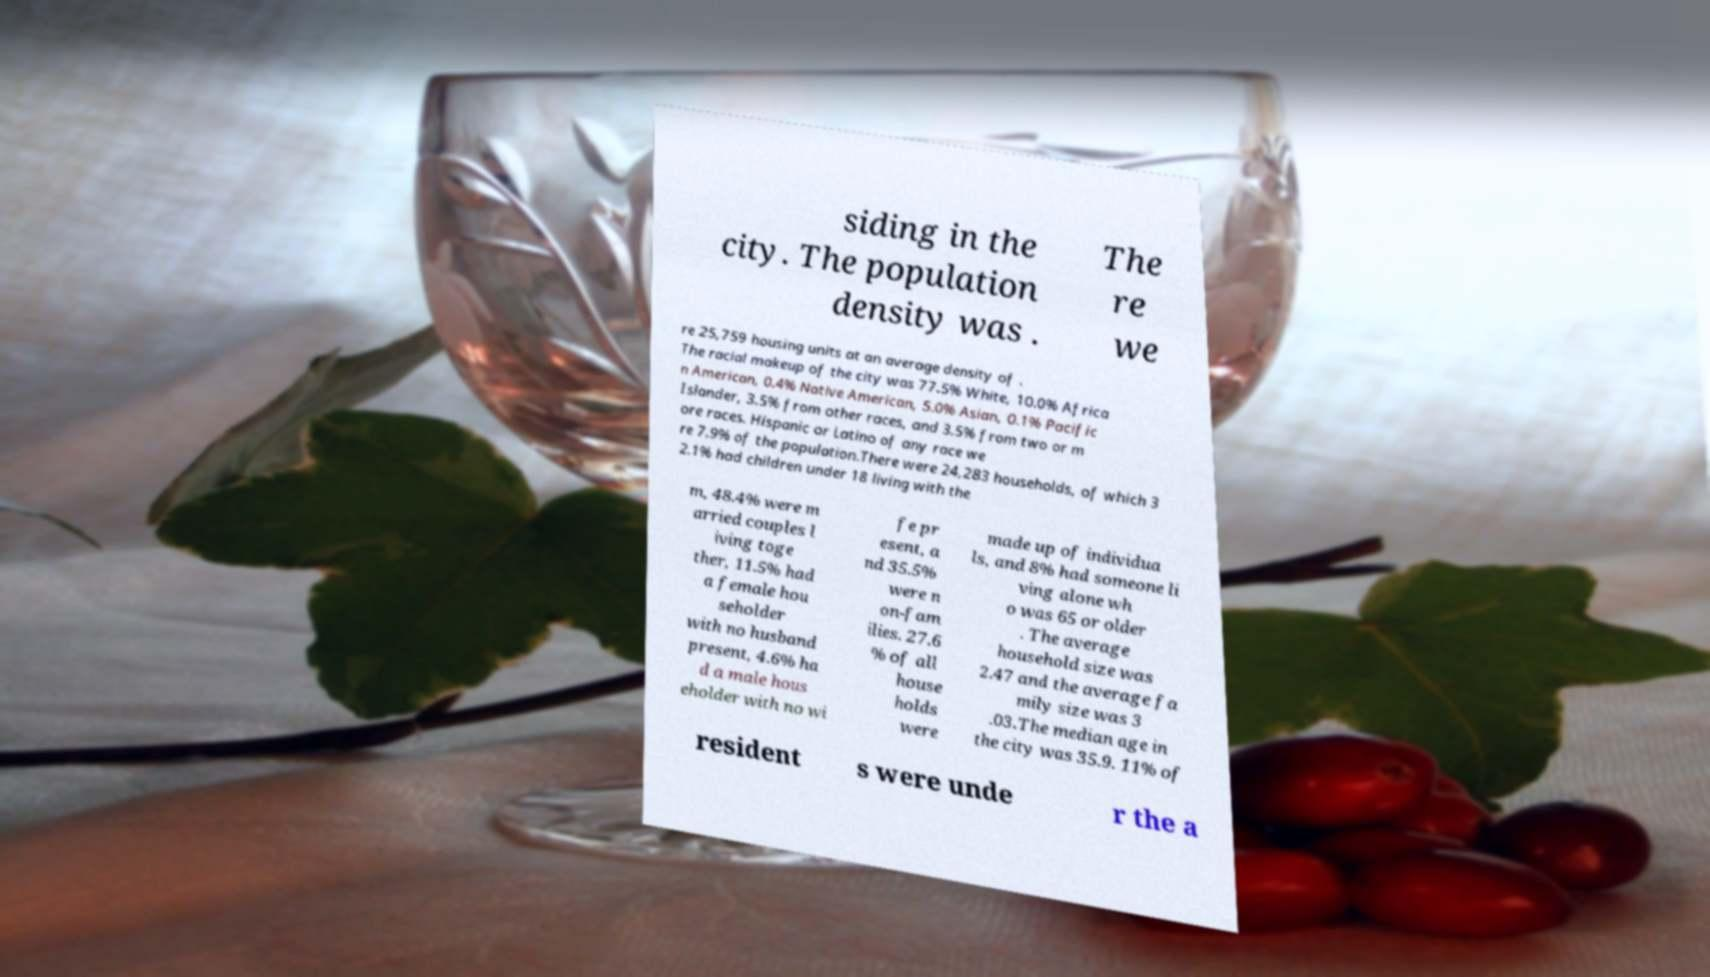I need the written content from this picture converted into text. Can you do that? siding in the city. The population density was . The re we re 25,759 housing units at an average density of . The racial makeup of the city was 77.5% White, 10.0% Africa n American, 0.4% Native American, 5.0% Asian, 0.1% Pacific Islander, 3.5% from other races, and 3.5% from two or m ore races. Hispanic or Latino of any race we re 7.9% of the population.There were 24,283 households, of which 3 2.1% had children under 18 living with the m, 48.4% were m arried couples l iving toge ther, 11.5% had a female hou seholder with no husband present, 4.6% ha d a male hous eholder with no wi fe pr esent, a nd 35.5% were n on-fam ilies. 27.6 % of all house holds were made up of individua ls, and 8% had someone li ving alone wh o was 65 or older . The average household size was 2.47 and the average fa mily size was 3 .03.The median age in the city was 35.9. 11% of resident s were unde r the a 